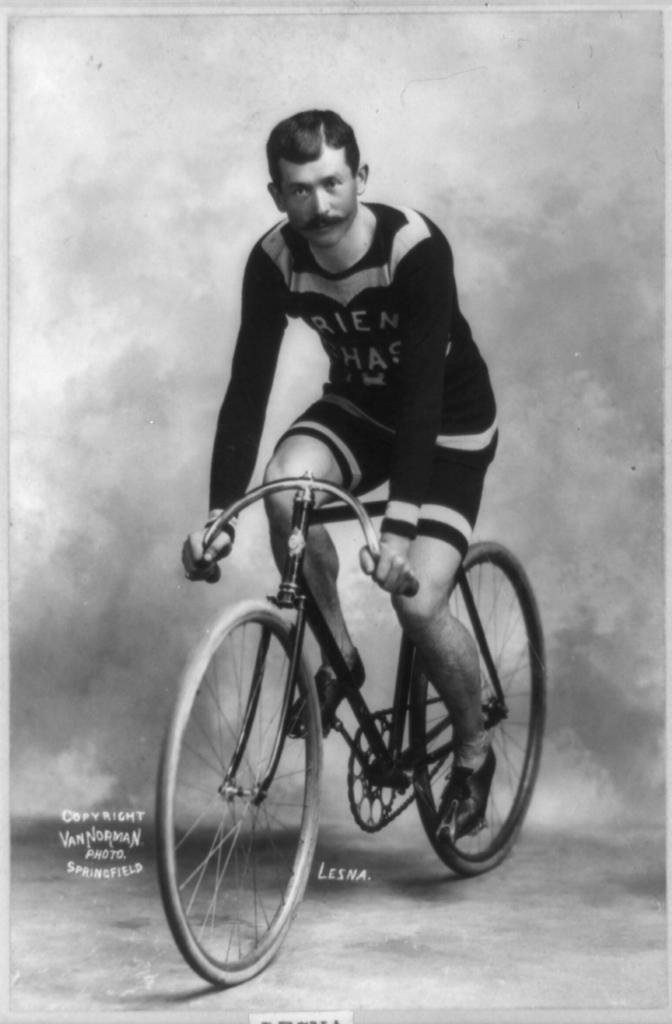What is the main subject of the image? There is a person in the image. What is the person doing in the image? The person is sitting on a bicycle. What type of clothing is the person wearing? The person is wearing a t-shirt and shorts. How many wheels does the bicycle have? The bicycle has two wheels. What feature of the bicycle is used for propulsion? The bicycle has pedals for propulsion. What facial feature does the person have? The person has a moustache. What type of fruit is the person holding in the image? There is no fruit present in the image; the person is sitting on a bicycle. Can you tell me what language the person is speaking in the image? There is no indication of the person speaking in the image, so it cannot be determined which language they might be using. 